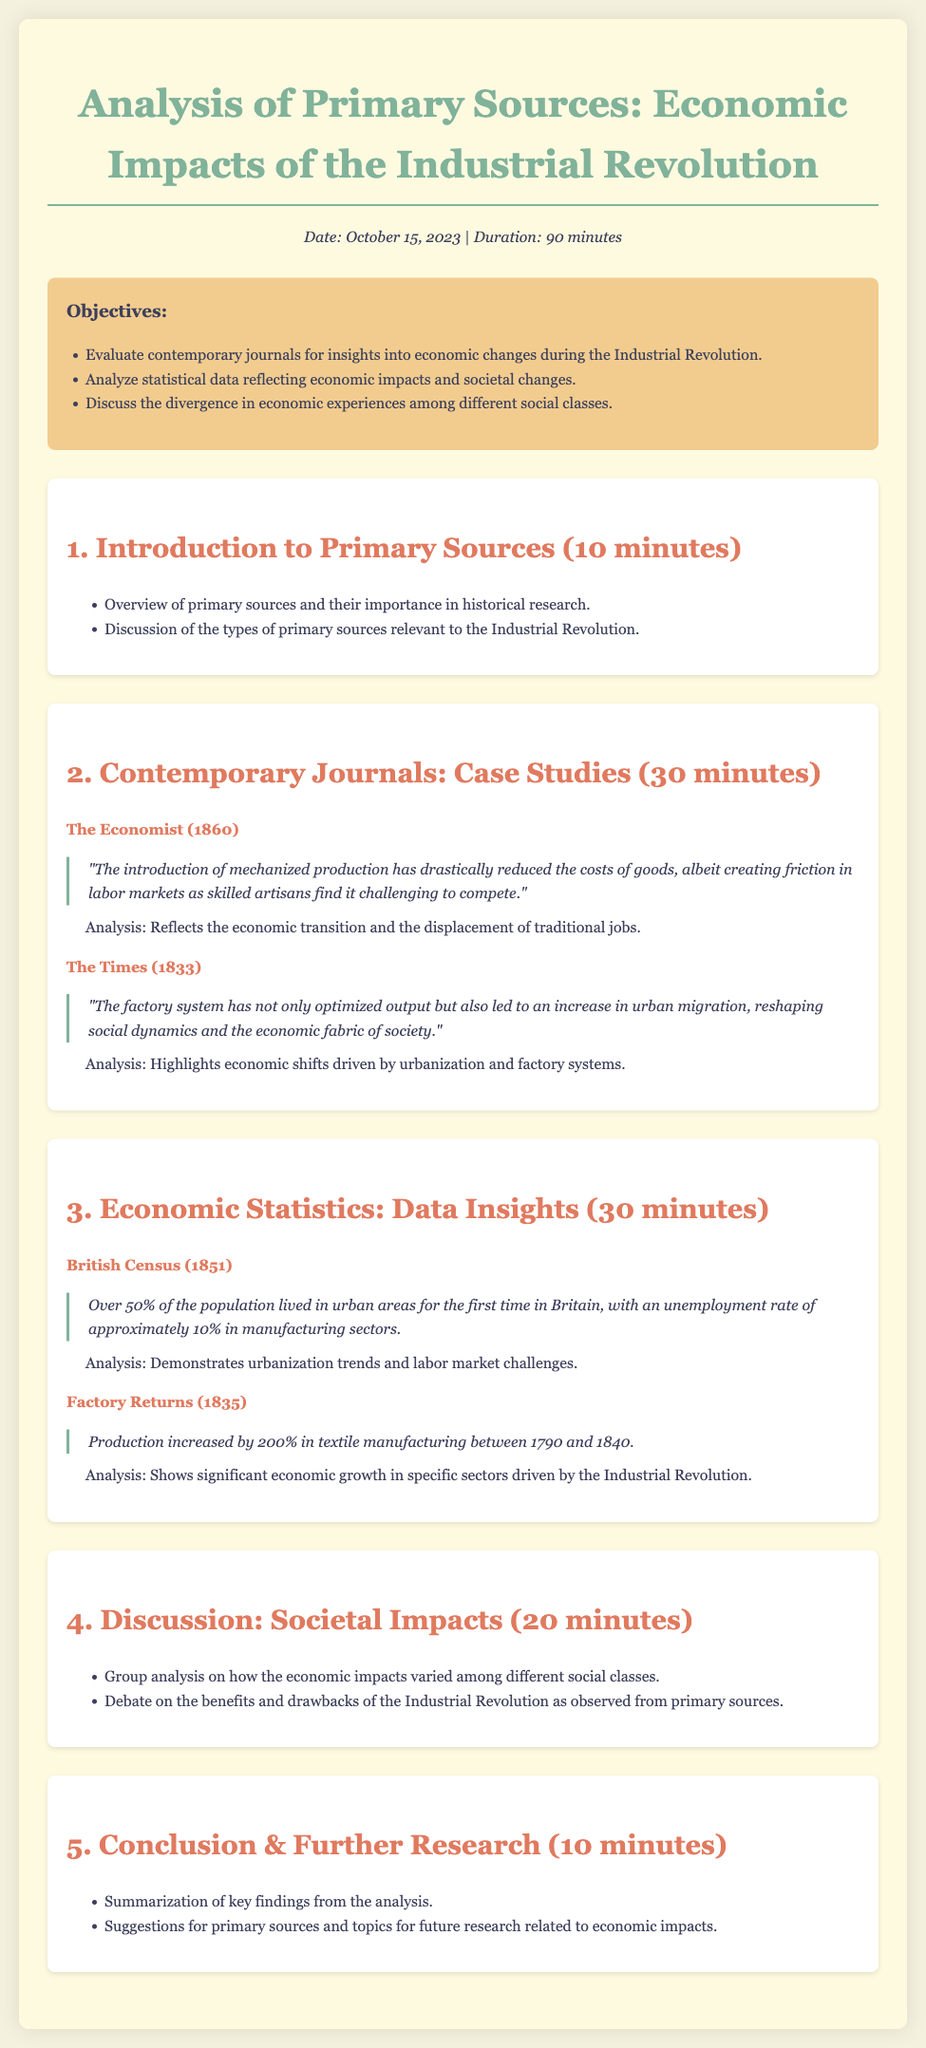What is the date of the agenda? The document states the date of the agenda as October 15, 2023.
Answer: October 15, 2023 How long is the duration of the session? The duration mentioned in the document is 90 minutes.
Answer: 90 minutes What percentage of the population lived in urban areas according to the British Census of 1851? The document notes that over 50% of the population lived in urban areas for the first time in Britain.
Answer: Over 50% Which journal published a case study on mechanized production in 1860? The document identifies The Economist as the journal that published insights on mechanized production in 1860.
Answer: The Economist What was the unemployment rate in manufacturing sectors according to the British Census (1851)? The statistic provided indicates an unemployment rate of approximately 10% in manufacturing sectors.
Answer: Approximately 10% What significant increase in textile manufacturing production is noted between 1790 and 1840? The document mentions a production increase of 200% in textile manufacturing during that period.
Answer: 200% What key societal change does The Times (1833) excerpt highlight? The excerpt from The Times emphasizes urban migration as a significant societal change due to factory systems.
Answer: Urban migration What is the primary focus of the discussion segment in the agenda? The discussion segment focuses on how economic impacts varied among different social classes.
Answer: Economic impacts among social classes Which topic is suggested for further research in the conclusion? The conclusion suggests further research related to economic impacts as a topic for exploration.
Answer: Economic impacts 